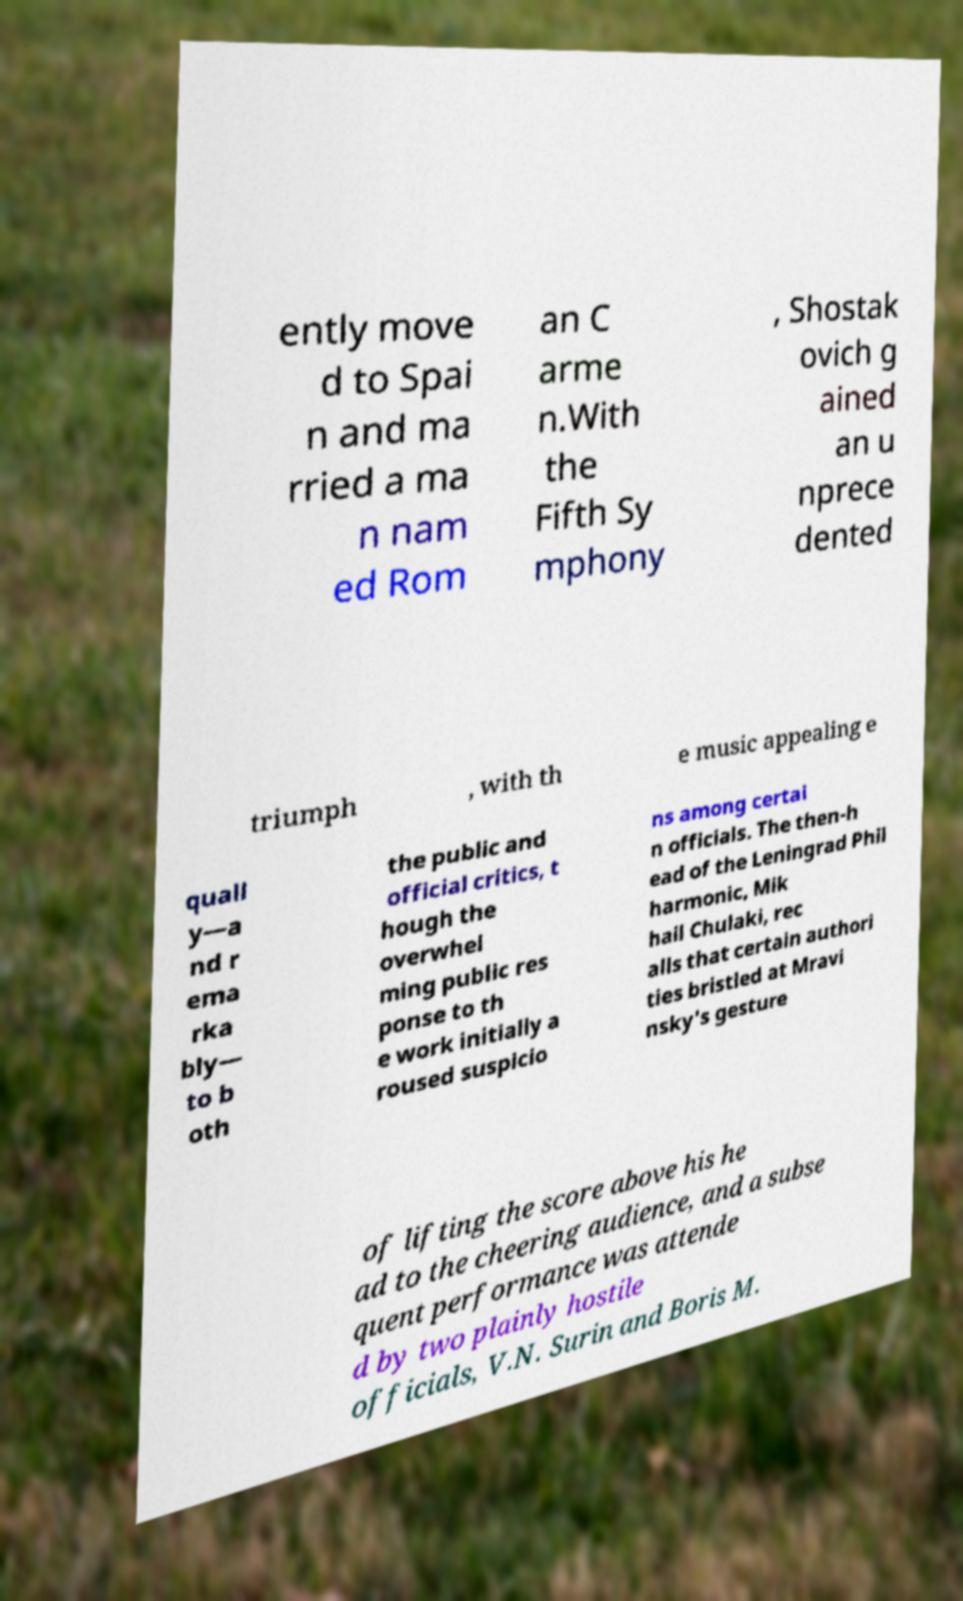What messages or text are displayed in this image? I need them in a readable, typed format. ently move d to Spai n and ma rried a ma n nam ed Rom an C arme n.With the Fifth Sy mphony , Shostak ovich g ained an u nprece dented triumph , with th e music appealing e quall y—a nd r ema rka bly— to b oth the public and official critics, t hough the overwhel ming public res ponse to th e work initially a roused suspicio ns among certai n officials. The then-h ead of the Leningrad Phil harmonic, Mik hail Chulaki, rec alls that certain authori ties bristled at Mravi nsky's gesture of lifting the score above his he ad to the cheering audience, and a subse quent performance was attende d by two plainly hostile officials, V.N. Surin and Boris M. 